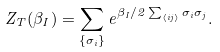<formula> <loc_0><loc_0><loc_500><loc_500>Z _ { T } ( \beta _ { I } ) = \sum _ { \{ \sigma _ { i } \} } e ^ { \beta _ { I } / 2 \sum _ { \left \langle i j \right \rangle } \sigma _ { i } \sigma _ { j } } .</formula> 